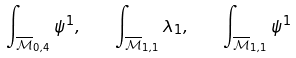<formula> <loc_0><loc_0><loc_500><loc_500>\int _ { \overline { \mathcal { M } } _ { 0 , 4 } } \psi ^ { 1 } , \quad \int _ { \overline { \mathcal { M } } _ { 1 , 1 } } \lambda _ { 1 } , \quad \int _ { \overline { \mathcal { M } } _ { 1 , 1 } } \psi ^ { 1 }</formula> 